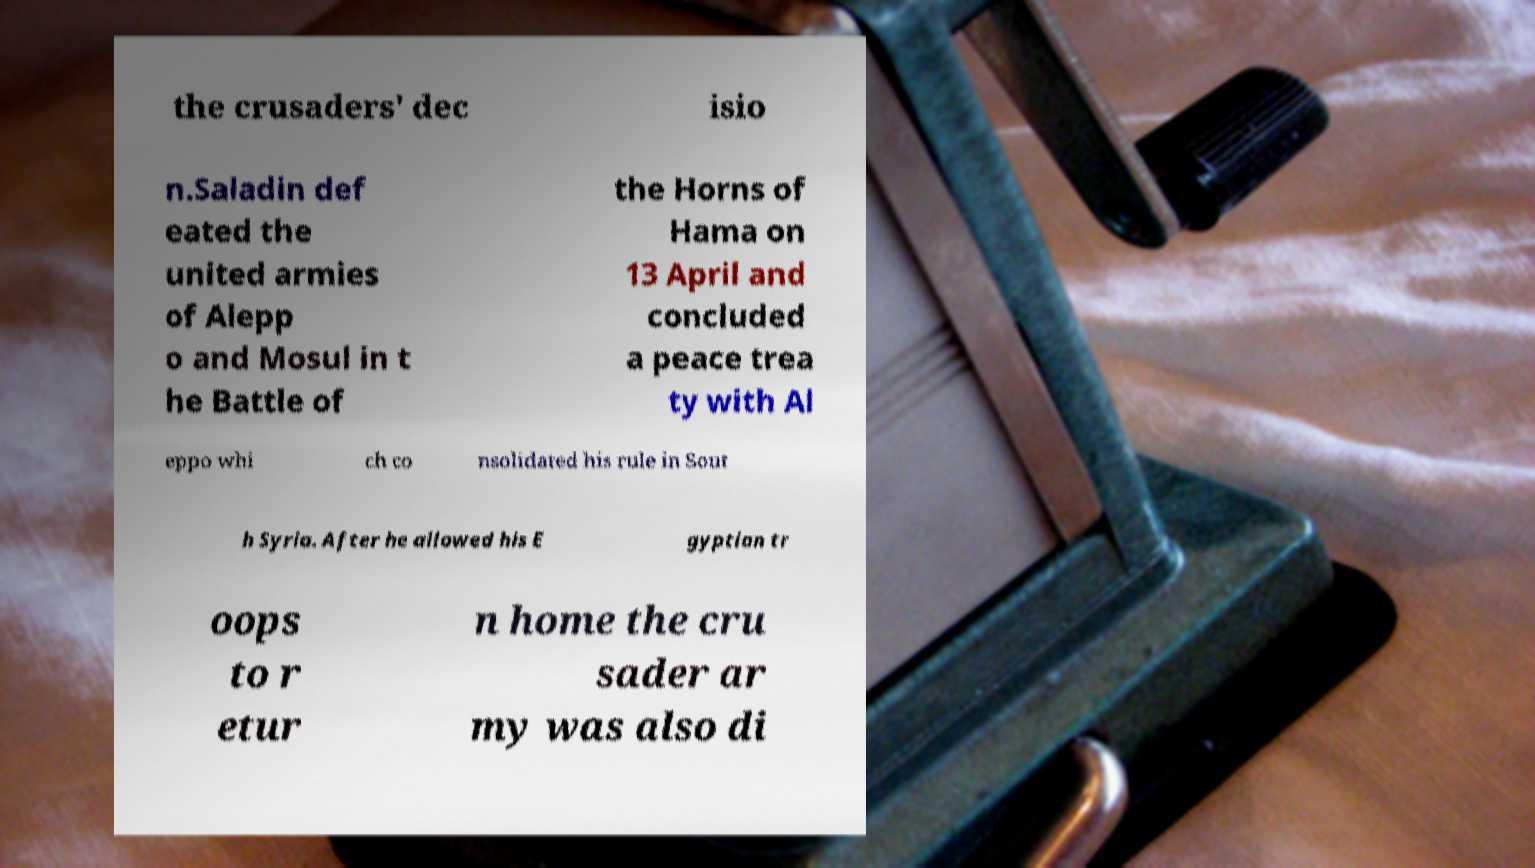Please identify and transcribe the text found in this image. the crusaders' dec isio n.Saladin def eated the united armies of Alepp o and Mosul in t he Battle of the Horns of Hama on 13 April and concluded a peace trea ty with Al eppo whi ch co nsolidated his rule in Sout h Syria. After he allowed his E gyptian tr oops to r etur n home the cru sader ar my was also di 